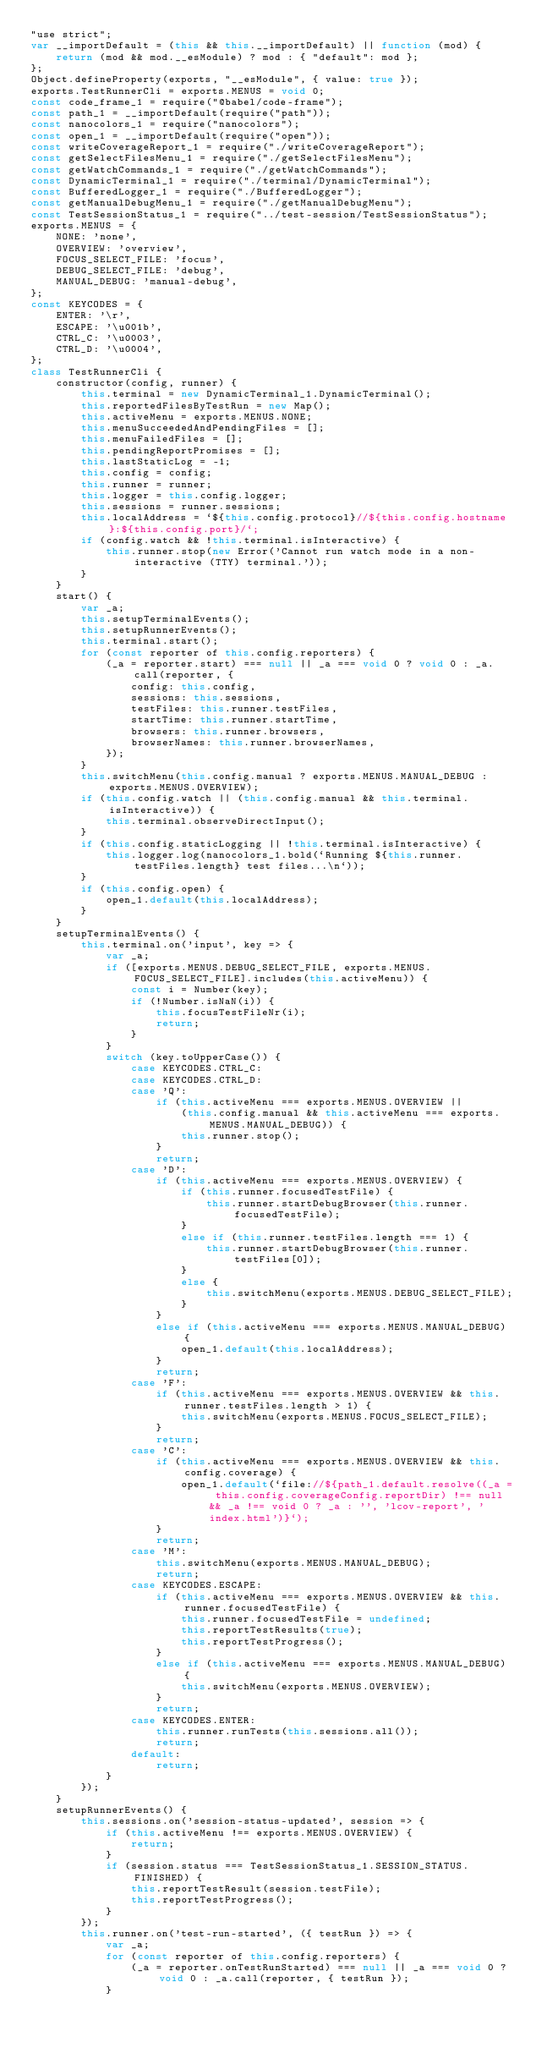<code> <loc_0><loc_0><loc_500><loc_500><_JavaScript_>"use strict";
var __importDefault = (this && this.__importDefault) || function (mod) {
    return (mod && mod.__esModule) ? mod : { "default": mod };
};
Object.defineProperty(exports, "__esModule", { value: true });
exports.TestRunnerCli = exports.MENUS = void 0;
const code_frame_1 = require("@babel/code-frame");
const path_1 = __importDefault(require("path"));
const nanocolors_1 = require("nanocolors");
const open_1 = __importDefault(require("open"));
const writeCoverageReport_1 = require("./writeCoverageReport");
const getSelectFilesMenu_1 = require("./getSelectFilesMenu");
const getWatchCommands_1 = require("./getWatchCommands");
const DynamicTerminal_1 = require("./terminal/DynamicTerminal");
const BufferedLogger_1 = require("./BufferedLogger");
const getManualDebugMenu_1 = require("./getManualDebugMenu");
const TestSessionStatus_1 = require("../test-session/TestSessionStatus");
exports.MENUS = {
    NONE: 'none',
    OVERVIEW: 'overview',
    FOCUS_SELECT_FILE: 'focus',
    DEBUG_SELECT_FILE: 'debug',
    MANUAL_DEBUG: 'manual-debug',
};
const KEYCODES = {
    ENTER: '\r',
    ESCAPE: '\u001b',
    CTRL_C: '\u0003',
    CTRL_D: '\u0004',
};
class TestRunnerCli {
    constructor(config, runner) {
        this.terminal = new DynamicTerminal_1.DynamicTerminal();
        this.reportedFilesByTestRun = new Map();
        this.activeMenu = exports.MENUS.NONE;
        this.menuSucceededAndPendingFiles = [];
        this.menuFailedFiles = [];
        this.pendingReportPromises = [];
        this.lastStaticLog = -1;
        this.config = config;
        this.runner = runner;
        this.logger = this.config.logger;
        this.sessions = runner.sessions;
        this.localAddress = `${this.config.protocol}//${this.config.hostname}:${this.config.port}/`;
        if (config.watch && !this.terminal.isInteractive) {
            this.runner.stop(new Error('Cannot run watch mode in a non-interactive (TTY) terminal.'));
        }
    }
    start() {
        var _a;
        this.setupTerminalEvents();
        this.setupRunnerEvents();
        this.terminal.start();
        for (const reporter of this.config.reporters) {
            (_a = reporter.start) === null || _a === void 0 ? void 0 : _a.call(reporter, {
                config: this.config,
                sessions: this.sessions,
                testFiles: this.runner.testFiles,
                startTime: this.runner.startTime,
                browsers: this.runner.browsers,
                browserNames: this.runner.browserNames,
            });
        }
        this.switchMenu(this.config.manual ? exports.MENUS.MANUAL_DEBUG : exports.MENUS.OVERVIEW);
        if (this.config.watch || (this.config.manual && this.terminal.isInteractive)) {
            this.terminal.observeDirectInput();
        }
        if (this.config.staticLogging || !this.terminal.isInteractive) {
            this.logger.log(nanocolors_1.bold(`Running ${this.runner.testFiles.length} test files...\n`));
        }
        if (this.config.open) {
            open_1.default(this.localAddress);
        }
    }
    setupTerminalEvents() {
        this.terminal.on('input', key => {
            var _a;
            if ([exports.MENUS.DEBUG_SELECT_FILE, exports.MENUS.FOCUS_SELECT_FILE].includes(this.activeMenu)) {
                const i = Number(key);
                if (!Number.isNaN(i)) {
                    this.focusTestFileNr(i);
                    return;
                }
            }
            switch (key.toUpperCase()) {
                case KEYCODES.CTRL_C:
                case KEYCODES.CTRL_D:
                case 'Q':
                    if (this.activeMenu === exports.MENUS.OVERVIEW ||
                        (this.config.manual && this.activeMenu === exports.MENUS.MANUAL_DEBUG)) {
                        this.runner.stop();
                    }
                    return;
                case 'D':
                    if (this.activeMenu === exports.MENUS.OVERVIEW) {
                        if (this.runner.focusedTestFile) {
                            this.runner.startDebugBrowser(this.runner.focusedTestFile);
                        }
                        else if (this.runner.testFiles.length === 1) {
                            this.runner.startDebugBrowser(this.runner.testFiles[0]);
                        }
                        else {
                            this.switchMenu(exports.MENUS.DEBUG_SELECT_FILE);
                        }
                    }
                    else if (this.activeMenu === exports.MENUS.MANUAL_DEBUG) {
                        open_1.default(this.localAddress);
                    }
                    return;
                case 'F':
                    if (this.activeMenu === exports.MENUS.OVERVIEW && this.runner.testFiles.length > 1) {
                        this.switchMenu(exports.MENUS.FOCUS_SELECT_FILE);
                    }
                    return;
                case 'C':
                    if (this.activeMenu === exports.MENUS.OVERVIEW && this.config.coverage) {
                        open_1.default(`file://${path_1.default.resolve((_a = this.config.coverageConfig.reportDir) !== null && _a !== void 0 ? _a : '', 'lcov-report', 'index.html')}`);
                    }
                    return;
                case 'M':
                    this.switchMenu(exports.MENUS.MANUAL_DEBUG);
                    return;
                case KEYCODES.ESCAPE:
                    if (this.activeMenu === exports.MENUS.OVERVIEW && this.runner.focusedTestFile) {
                        this.runner.focusedTestFile = undefined;
                        this.reportTestResults(true);
                        this.reportTestProgress();
                    }
                    else if (this.activeMenu === exports.MENUS.MANUAL_DEBUG) {
                        this.switchMenu(exports.MENUS.OVERVIEW);
                    }
                    return;
                case KEYCODES.ENTER:
                    this.runner.runTests(this.sessions.all());
                    return;
                default:
                    return;
            }
        });
    }
    setupRunnerEvents() {
        this.sessions.on('session-status-updated', session => {
            if (this.activeMenu !== exports.MENUS.OVERVIEW) {
                return;
            }
            if (session.status === TestSessionStatus_1.SESSION_STATUS.FINISHED) {
                this.reportTestResult(session.testFile);
                this.reportTestProgress();
            }
        });
        this.runner.on('test-run-started', ({ testRun }) => {
            var _a;
            for (const reporter of this.config.reporters) {
                (_a = reporter.onTestRunStarted) === null || _a === void 0 ? void 0 : _a.call(reporter, { testRun });
            }</code> 